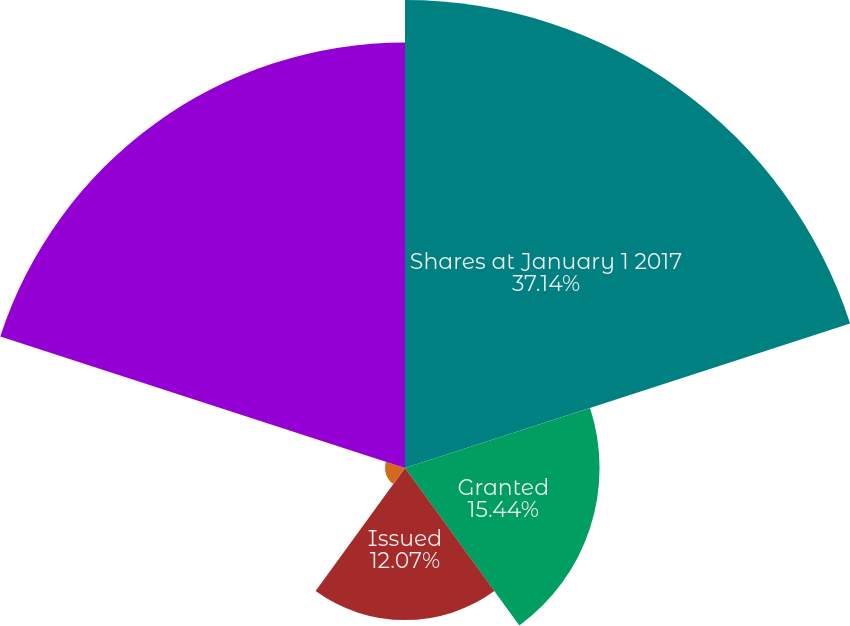<chart> <loc_0><loc_0><loc_500><loc_500><pie_chart><fcel>Shares at January 1 2017<fcel>Granted<fcel>Issued<fcel>Canceled/forfeited/adjusted<fcel>Shares at December 31 2017<nl><fcel>37.14%<fcel>15.44%<fcel>12.07%<fcel>1.58%<fcel>33.77%<nl></chart> 